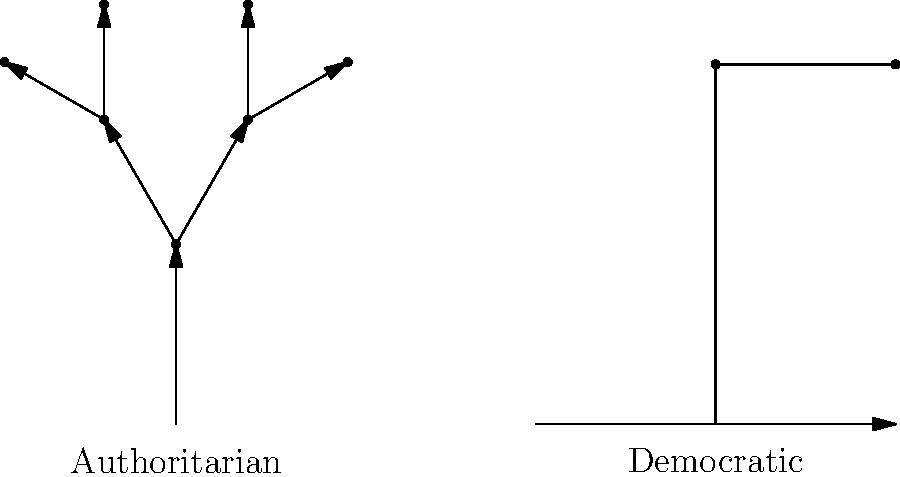Analyze the family tree structures in the image. Which political system is more likely to exhibit a complex, multi-generational family tree in positions of power, and why is this problematic from the perspective of democratic governance? 1. The image presents two contrasting family tree structures:
   - Left: A complex, multi-generational tree (Authoritarian)
   - Right: A simple, single-generation structure (Democratic)

2. The authoritarian system shows:
   - Multiple generations of power transfer
   - Branching structure indicating nepotism and hereditary rule
   - Concentration of power within a family lineage

3. The democratic system shows:
   - Limited family involvement in power
   - Horizontal structure suggesting equal opportunities
   - No indication of hereditary power transfer

4. Problematic aspects of the authoritarian structure:
   a) Nepotism: Family members are favored over qualified individuals
   b) Limited meritocracy: Power is inherited rather than earned
   c) Lack of diverse perspectives: Decision-making is confined to one family
   d) Reduced accountability: Family loyalty may override public interest
   e) Stagnation: Resistance to change and new ideas

5. Democratic principles violated:
   - Equal opportunity
   - Fair representation
   - Checks and balances
   - Separation of powers

6. Long-term consequences:
   - Erosion of institutions
   - Public disillusionment
   - Potential for abuse of power
   - Hindered social and economic progress
Answer: Authoritarian; it undermines meritocracy, accountability, and democratic principles. 